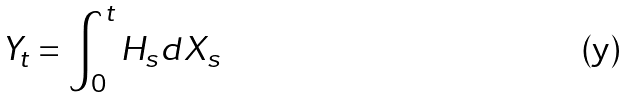<formula> <loc_0><loc_0><loc_500><loc_500>Y _ { t } = \int _ { 0 } ^ { t } H _ { s } d X _ { s }</formula> 